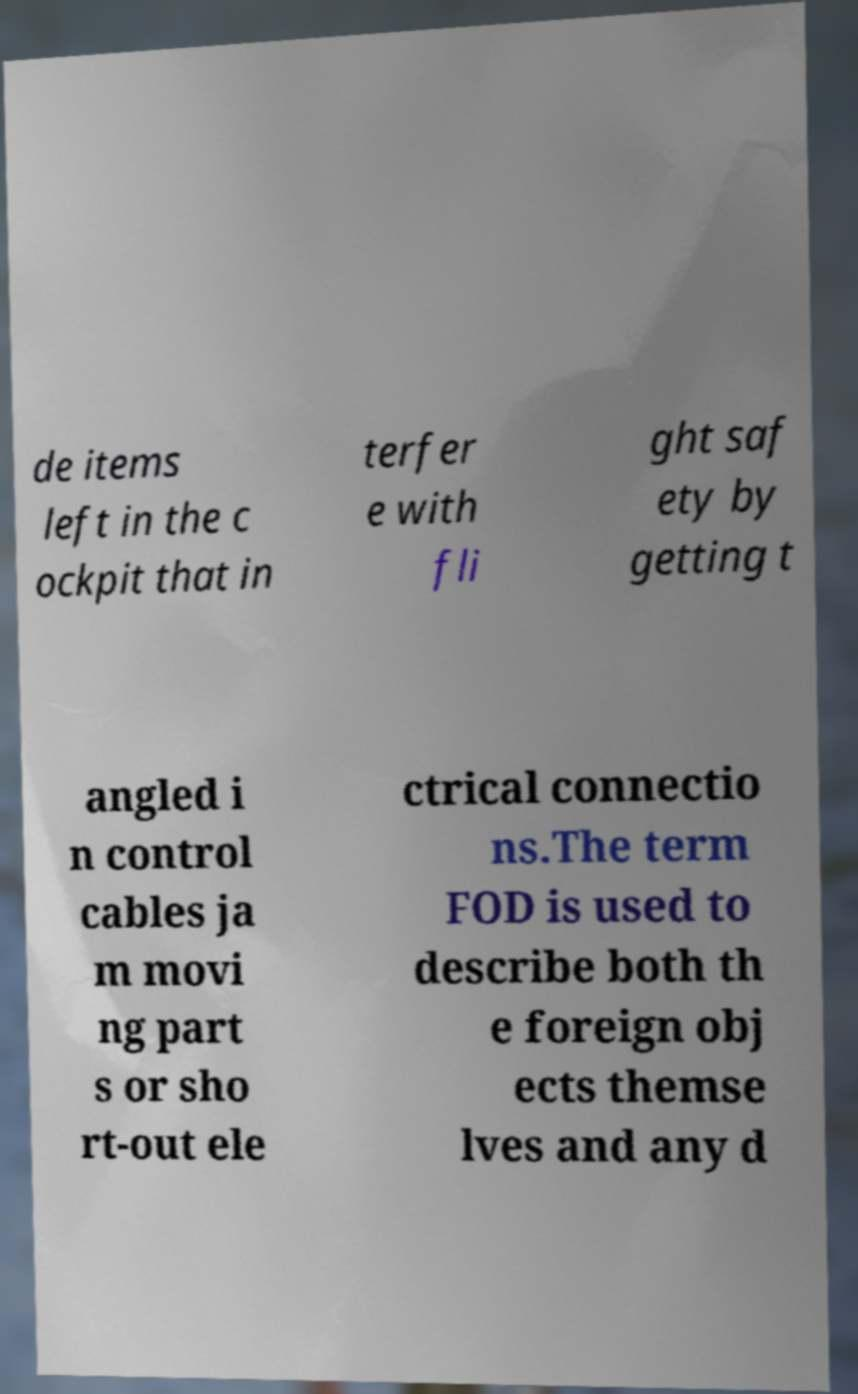What messages or text are displayed in this image? I need them in a readable, typed format. de items left in the c ockpit that in terfer e with fli ght saf ety by getting t angled i n control cables ja m movi ng part s or sho rt-out ele ctrical connectio ns.The term FOD is used to describe both th e foreign obj ects themse lves and any d 